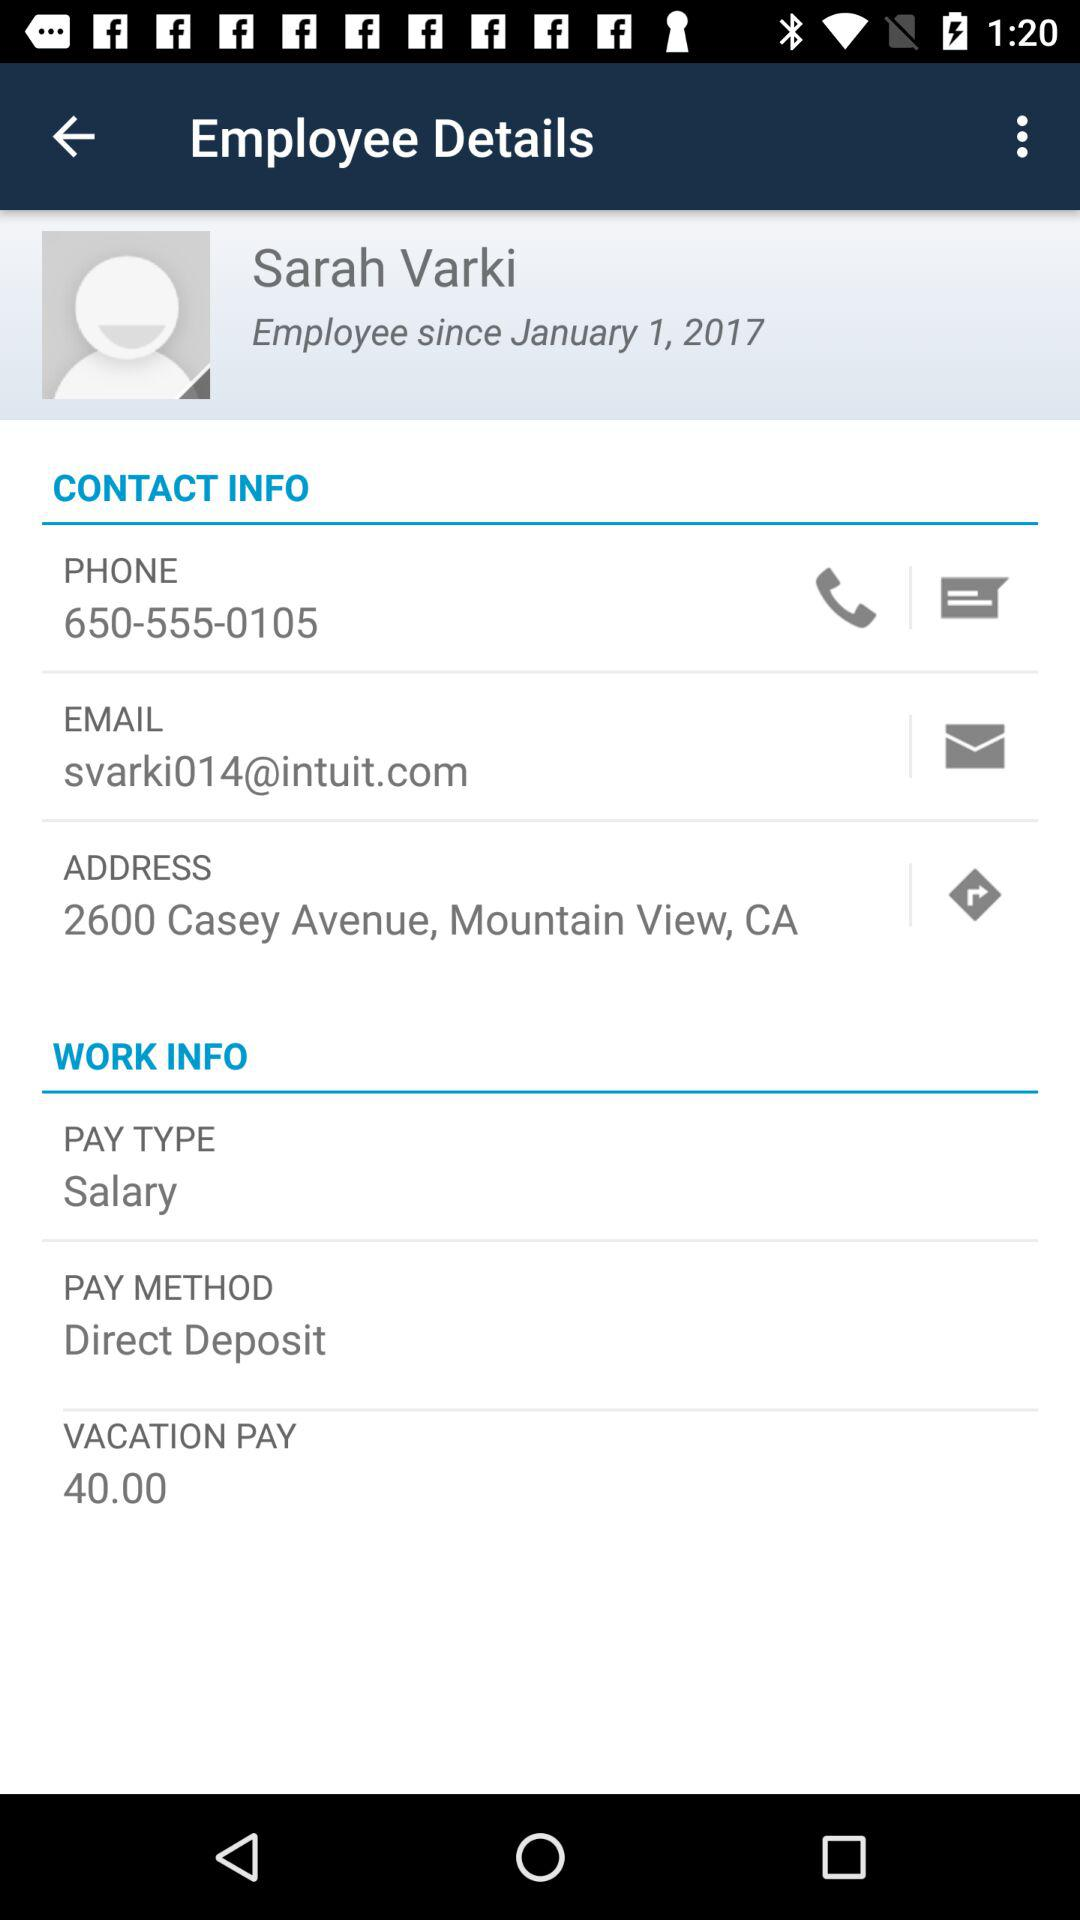What is the payment method? The payment method is "Direct Deposit". 